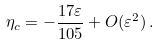<formula> <loc_0><loc_0><loc_500><loc_500>\eta _ { c } = - \frac { 1 7 \varepsilon } { 1 0 5 } + O ( \varepsilon ^ { 2 } ) \, .</formula> 